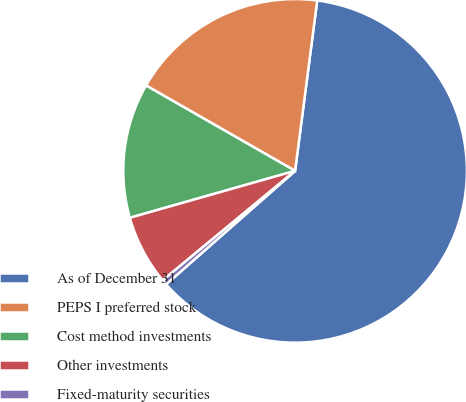<chart> <loc_0><loc_0><loc_500><loc_500><pie_chart><fcel>As of December 31<fcel>PEPS I preferred stock<fcel>Cost method investments<fcel>Other investments<fcel>Fixed-maturity securities<nl><fcel>61.46%<fcel>18.78%<fcel>12.68%<fcel>6.59%<fcel>0.49%<nl></chart> 